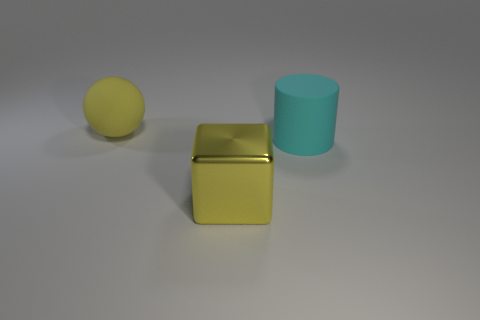Add 3 big cyan matte cylinders. How many objects exist? 6 Subtract 1 cylinders. How many cylinders are left? 0 Subtract all cylinders. How many objects are left? 2 Add 3 large purple rubber cubes. How many large purple rubber cubes exist? 3 Subtract 0 red balls. How many objects are left? 3 Subtract all brown balls. Subtract all blue cylinders. How many balls are left? 1 Subtract all large rubber cylinders. Subtract all big matte cylinders. How many objects are left? 1 Add 2 large cyan cylinders. How many large cyan cylinders are left? 3 